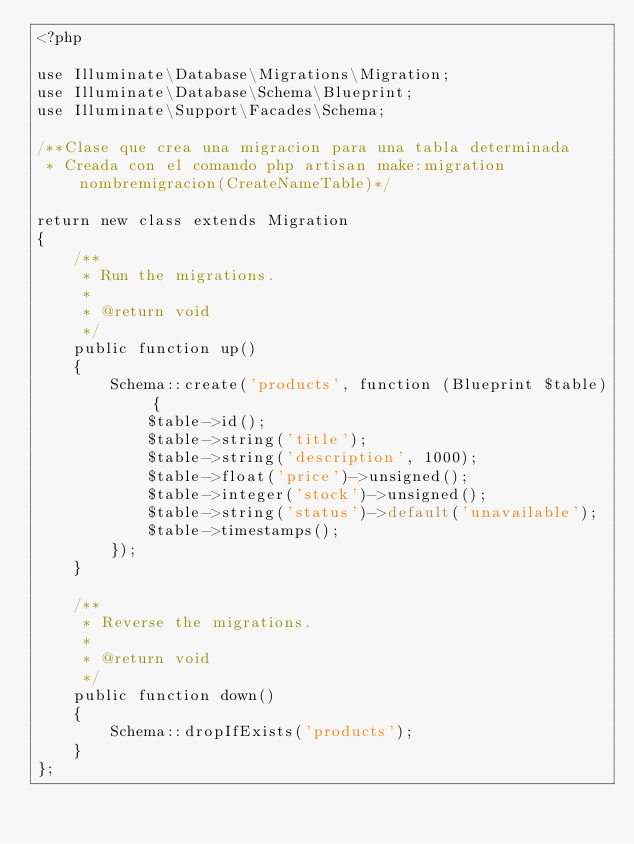Convert code to text. <code><loc_0><loc_0><loc_500><loc_500><_PHP_><?php

use Illuminate\Database\Migrations\Migration;
use Illuminate\Database\Schema\Blueprint;
use Illuminate\Support\Facades\Schema;

/**Clase que crea una migracion para una tabla determinada
 * Creada con el comando php artisan make:migration nombremigracion(CreateNameTable)*/

return new class extends Migration
{
    /**
     * Run the migrations.
     *
     * @return void
     */
    public function up()
    {
        Schema::create('products', function (Blueprint $table) {
            $table->id();
            $table->string('title');
            $table->string('description', 1000);
            $table->float('price')->unsigned();
            $table->integer('stock')->unsigned();
            $table->string('status')->default('unavailable');
            $table->timestamps();
        });
    }

    /**
     * Reverse the migrations.
     *
     * @return void
     */
    public function down()
    {
        Schema::dropIfExists('products');
    }
};
</code> 